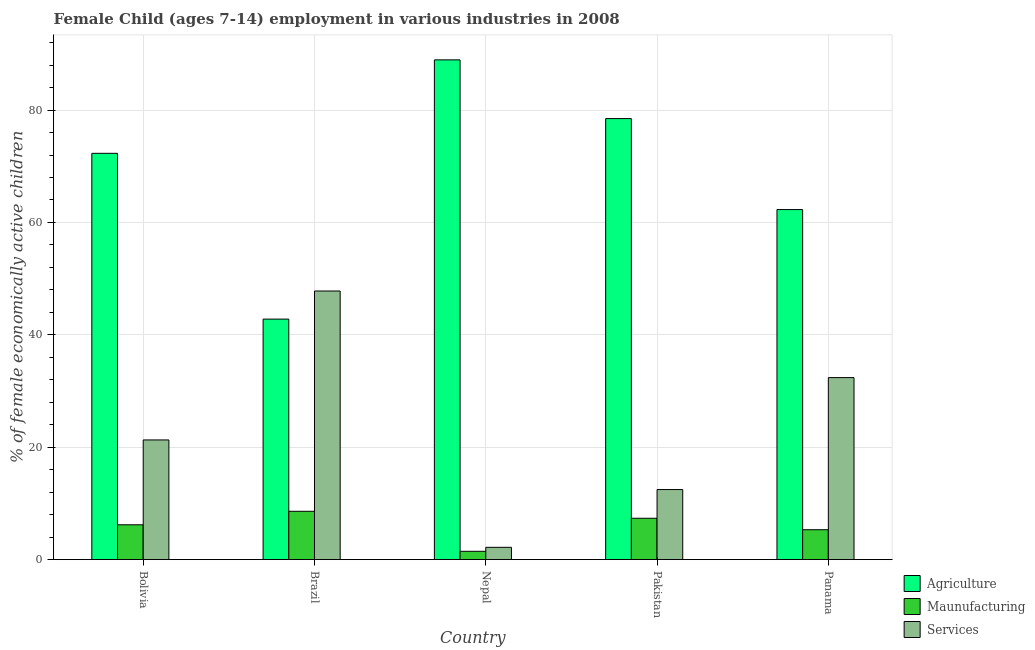How many groups of bars are there?
Make the answer very short. 5. How many bars are there on the 1st tick from the right?
Provide a short and direct response. 3. What is the label of the 2nd group of bars from the left?
Your answer should be compact. Brazil. In how many cases, is the number of bars for a given country not equal to the number of legend labels?
Offer a terse response. 0. What is the percentage of economically active children in services in Pakistan?
Provide a short and direct response. 12.47. Across all countries, what is the maximum percentage of economically active children in agriculture?
Your answer should be very brief. 88.93. Across all countries, what is the minimum percentage of economically active children in manufacturing?
Ensure brevity in your answer.  1.48. In which country was the percentage of economically active children in agriculture maximum?
Offer a terse response. Nepal. In which country was the percentage of economically active children in services minimum?
Make the answer very short. Nepal. What is the total percentage of economically active children in manufacturing in the graph?
Provide a short and direct response. 28.96. What is the difference between the percentage of economically active children in agriculture in Bolivia and that in Nepal?
Keep it short and to the point. -16.63. What is the difference between the percentage of economically active children in agriculture in Bolivia and the percentage of economically active children in manufacturing in Panama?
Make the answer very short. 66.98. What is the average percentage of economically active children in agriculture per country?
Keep it short and to the point. 68.96. What is the difference between the percentage of economically active children in services and percentage of economically active children in manufacturing in Panama?
Provide a short and direct response. 27.07. In how many countries, is the percentage of economically active children in agriculture greater than 32 %?
Provide a succinct answer. 5. What is the ratio of the percentage of economically active children in services in Bolivia to that in Brazil?
Make the answer very short. 0.45. Is the percentage of economically active children in services in Bolivia less than that in Pakistan?
Provide a succinct answer. No. What is the difference between the highest and the second highest percentage of economically active children in agriculture?
Provide a short and direct response. 10.45. What is the difference between the highest and the lowest percentage of economically active children in services?
Your response must be concise. 45.61. In how many countries, is the percentage of economically active children in agriculture greater than the average percentage of economically active children in agriculture taken over all countries?
Give a very brief answer. 3. Is the sum of the percentage of economically active children in services in Brazil and Pakistan greater than the maximum percentage of economically active children in manufacturing across all countries?
Your answer should be compact. Yes. What does the 3rd bar from the left in Brazil represents?
Offer a terse response. Services. What does the 1st bar from the right in Brazil represents?
Make the answer very short. Services. Is it the case that in every country, the sum of the percentage of economically active children in agriculture and percentage of economically active children in manufacturing is greater than the percentage of economically active children in services?
Offer a very short reply. Yes. Are all the bars in the graph horizontal?
Offer a very short reply. No. How many countries are there in the graph?
Your response must be concise. 5. What is the difference between two consecutive major ticks on the Y-axis?
Provide a succinct answer. 20. Are the values on the major ticks of Y-axis written in scientific E-notation?
Your answer should be very brief. No. Does the graph contain grids?
Your answer should be compact. Yes. Where does the legend appear in the graph?
Give a very brief answer. Bottom right. How are the legend labels stacked?
Make the answer very short. Vertical. What is the title of the graph?
Offer a very short reply. Female Child (ages 7-14) employment in various industries in 2008. Does "Agricultural raw materials" appear as one of the legend labels in the graph?
Provide a succinct answer. No. What is the label or title of the Y-axis?
Provide a succinct answer. % of female economically active children. What is the % of female economically active children in Agriculture in Bolivia?
Offer a very short reply. 72.3. What is the % of female economically active children of Services in Bolivia?
Make the answer very short. 21.3. What is the % of female economically active children of Agriculture in Brazil?
Keep it short and to the point. 42.8. What is the % of female economically active children of Services in Brazil?
Ensure brevity in your answer.  47.8. What is the % of female economically active children of Agriculture in Nepal?
Your response must be concise. 88.93. What is the % of female economically active children of Maunufacturing in Nepal?
Provide a short and direct response. 1.48. What is the % of female economically active children in Services in Nepal?
Offer a very short reply. 2.19. What is the % of female economically active children of Agriculture in Pakistan?
Your answer should be very brief. 78.48. What is the % of female economically active children of Maunufacturing in Pakistan?
Offer a terse response. 7.36. What is the % of female economically active children in Services in Pakistan?
Make the answer very short. 12.47. What is the % of female economically active children of Agriculture in Panama?
Ensure brevity in your answer.  62.29. What is the % of female economically active children of Maunufacturing in Panama?
Provide a succinct answer. 5.32. What is the % of female economically active children in Services in Panama?
Your answer should be very brief. 32.39. Across all countries, what is the maximum % of female economically active children of Agriculture?
Provide a short and direct response. 88.93. Across all countries, what is the maximum % of female economically active children of Maunufacturing?
Make the answer very short. 8.6. Across all countries, what is the maximum % of female economically active children of Services?
Provide a succinct answer. 47.8. Across all countries, what is the minimum % of female economically active children in Agriculture?
Provide a short and direct response. 42.8. Across all countries, what is the minimum % of female economically active children in Maunufacturing?
Ensure brevity in your answer.  1.48. Across all countries, what is the minimum % of female economically active children of Services?
Your answer should be very brief. 2.19. What is the total % of female economically active children in Agriculture in the graph?
Provide a short and direct response. 344.8. What is the total % of female economically active children of Maunufacturing in the graph?
Your response must be concise. 28.96. What is the total % of female economically active children in Services in the graph?
Provide a short and direct response. 116.15. What is the difference between the % of female economically active children in Agriculture in Bolivia and that in Brazil?
Give a very brief answer. 29.5. What is the difference between the % of female economically active children in Maunufacturing in Bolivia and that in Brazil?
Your answer should be compact. -2.4. What is the difference between the % of female economically active children of Services in Bolivia and that in Brazil?
Give a very brief answer. -26.5. What is the difference between the % of female economically active children of Agriculture in Bolivia and that in Nepal?
Provide a short and direct response. -16.63. What is the difference between the % of female economically active children in Maunufacturing in Bolivia and that in Nepal?
Provide a succinct answer. 4.72. What is the difference between the % of female economically active children in Services in Bolivia and that in Nepal?
Your response must be concise. 19.11. What is the difference between the % of female economically active children of Agriculture in Bolivia and that in Pakistan?
Ensure brevity in your answer.  -6.18. What is the difference between the % of female economically active children in Maunufacturing in Bolivia and that in Pakistan?
Your answer should be compact. -1.16. What is the difference between the % of female economically active children in Services in Bolivia and that in Pakistan?
Your answer should be very brief. 8.83. What is the difference between the % of female economically active children of Agriculture in Bolivia and that in Panama?
Make the answer very short. 10.01. What is the difference between the % of female economically active children of Maunufacturing in Bolivia and that in Panama?
Offer a very short reply. 0.88. What is the difference between the % of female economically active children in Services in Bolivia and that in Panama?
Keep it short and to the point. -11.09. What is the difference between the % of female economically active children in Agriculture in Brazil and that in Nepal?
Your response must be concise. -46.13. What is the difference between the % of female economically active children in Maunufacturing in Brazil and that in Nepal?
Offer a very short reply. 7.12. What is the difference between the % of female economically active children in Services in Brazil and that in Nepal?
Your response must be concise. 45.61. What is the difference between the % of female economically active children in Agriculture in Brazil and that in Pakistan?
Provide a succinct answer. -35.68. What is the difference between the % of female economically active children of Maunufacturing in Brazil and that in Pakistan?
Your answer should be compact. 1.24. What is the difference between the % of female economically active children of Services in Brazil and that in Pakistan?
Make the answer very short. 35.33. What is the difference between the % of female economically active children of Agriculture in Brazil and that in Panama?
Offer a very short reply. -19.49. What is the difference between the % of female economically active children in Maunufacturing in Brazil and that in Panama?
Your answer should be very brief. 3.28. What is the difference between the % of female economically active children of Services in Brazil and that in Panama?
Your response must be concise. 15.41. What is the difference between the % of female economically active children of Agriculture in Nepal and that in Pakistan?
Make the answer very short. 10.45. What is the difference between the % of female economically active children of Maunufacturing in Nepal and that in Pakistan?
Ensure brevity in your answer.  -5.88. What is the difference between the % of female economically active children of Services in Nepal and that in Pakistan?
Make the answer very short. -10.28. What is the difference between the % of female economically active children of Agriculture in Nepal and that in Panama?
Keep it short and to the point. 26.64. What is the difference between the % of female economically active children in Maunufacturing in Nepal and that in Panama?
Keep it short and to the point. -3.84. What is the difference between the % of female economically active children in Services in Nepal and that in Panama?
Your response must be concise. -30.2. What is the difference between the % of female economically active children in Agriculture in Pakistan and that in Panama?
Your answer should be very brief. 16.19. What is the difference between the % of female economically active children in Maunufacturing in Pakistan and that in Panama?
Give a very brief answer. 2.04. What is the difference between the % of female economically active children of Services in Pakistan and that in Panama?
Offer a terse response. -19.92. What is the difference between the % of female economically active children of Agriculture in Bolivia and the % of female economically active children of Maunufacturing in Brazil?
Provide a short and direct response. 63.7. What is the difference between the % of female economically active children of Maunufacturing in Bolivia and the % of female economically active children of Services in Brazil?
Your response must be concise. -41.6. What is the difference between the % of female economically active children of Agriculture in Bolivia and the % of female economically active children of Maunufacturing in Nepal?
Offer a very short reply. 70.82. What is the difference between the % of female economically active children in Agriculture in Bolivia and the % of female economically active children in Services in Nepal?
Your answer should be compact. 70.11. What is the difference between the % of female economically active children in Maunufacturing in Bolivia and the % of female economically active children in Services in Nepal?
Your answer should be compact. 4.01. What is the difference between the % of female economically active children in Agriculture in Bolivia and the % of female economically active children in Maunufacturing in Pakistan?
Ensure brevity in your answer.  64.94. What is the difference between the % of female economically active children of Agriculture in Bolivia and the % of female economically active children of Services in Pakistan?
Provide a succinct answer. 59.83. What is the difference between the % of female economically active children of Maunufacturing in Bolivia and the % of female economically active children of Services in Pakistan?
Keep it short and to the point. -6.27. What is the difference between the % of female economically active children in Agriculture in Bolivia and the % of female economically active children in Maunufacturing in Panama?
Ensure brevity in your answer.  66.98. What is the difference between the % of female economically active children in Agriculture in Bolivia and the % of female economically active children in Services in Panama?
Make the answer very short. 39.91. What is the difference between the % of female economically active children in Maunufacturing in Bolivia and the % of female economically active children in Services in Panama?
Make the answer very short. -26.19. What is the difference between the % of female economically active children in Agriculture in Brazil and the % of female economically active children in Maunufacturing in Nepal?
Your answer should be very brief. 41.32. What is the difference between the % of female economically active children of Agriculture in Brazil and the % of female economically active children of Services in Nepal?
Provide a short and direct response. 40.61. What is the difference between the % of female economically active children of Maunufacturing in Brazil and the % of female economically active children of Services in Nepal?
Keep it short and to the point. 6.41. What is the difference between the % of female economically active children in Agriculture in Brazil and the % of female economically active children in Maunufacturing in Pakistan?
Provide a succinct answer. 35.44. What is the difference between the % of female economically active children in Agriculture in Brazil and the % of female economically active children in Services in Pakistan?
Provide a short and direct response. 30.33. What is the difference between the % of female economically active children of Maunufacturing in Brazil and the % of female economically active children of Services in Pakistan?
Provide a short and direct response. -3.87. What is the difference between the % of female economically active children of Agriculture in Brazil and the % of female economically active children of Maunufacturing in Panama?
Offer a very short reply. 37.48. What is the difference between the % of female economically active children of Agriculture in Brazil and the % of female economically active children of Services in Panama?
Keep it short and to the point. 10.41. What is the difference between the % of female economically active children of Maunufacturing in Brazil and the % of female economically active children of Services in Panama?
Make the answer very short. -23.79. What is the difference between the % of female economically active children of Agriculture in Nepal and the % of female economically active children of Maunufacturing in Pakistan?
Your response must be concise. 81.57. What is the difference between the % of female economically active children of Agriculture in Nepal and the % of female economically active children of Services in Pakistan?
Give a very brief answer. 76.46. What is the difference between the % of female economically active children of Maunufacturing in Nepal and the % of female economically active children of Services in Pakistan?
Your answer should be compact. -10.99. What is the difference between the % of female economically active children of Agriculture in Nepal and the % of female economically active children of Maunufacturing in Panama?
Give a very brief answer. 83.61. What is the difference between the % of female economically active children of Agriculture in Nepal and the % of female economically active children of Services in Panama?
Your response must be concise. 56.54. What is the difference between the % of female economically active children in Maunufacturing in Nepal and the % of female economically active children in Services in Panama?
Provide a short and direct response. -30.91. What is the difference between the % of female economically active children in Agriculture in Pakistan and the % of female economically active children in Maunufacturing in Panama?
Your answer should be compact. 73.16. What is the difference between the % of female economically active children in Agriculture in Pakistan and the % of female economically active children in Services in Panama?
Your answer should be very brief. 46.09. What is the difference between the % of female economically active children in Maunufacturing in Pakistan and the % of female economically active children in Services in Panama?
Your answer should be very brief. -25.03. What is the average % of female economically active children of Agriculture per country?
Your answer should be very brief. 68.96. What is the average % of female economically active children of Maunufacturing per country?
Offer a terse response. 5.79. What is the average % of female economically active children of Services per country?
Offer a terse response. 23.23. What is the difference between the % of female economically active children of Agriculture and % of female economically active children of Maunufacturing in Bolivia?
Provide a succinct answer. 66.1. What is the difference between the % of female economically active children of Agriculture and % of female economically active children of Services in Bolivia?
Your response must be concise. 51. What is the difference between the % of female economically active children of Maunufacturing and % of female economically active children of Services in Bolivia?
Make the answer very short. -15.1. What is the difference between the % of female economically active children in Agriculture and % of female economically active children in Maunufacturing in Brazil?
Your response must be concise. 34.2. What is the difference between the % of female economically active children in Agriculture and % of female economically active children in Services in Brazil?
Your answer should be compact. -5. What is the difference between the % of female economically active children in Maunufacturing and % of female economically active children in Services in Brazil?
Offer a very short reply. -39.2. What is the difference between the % of female economically active children in Agriculture and % of female economically active children in Maunufacturing in Nepal?
Make the answer very short. 87.45. What is the difference between the % of female economically active children of Agriculture and % of female economically active children of Services in Nepal?
Offer a very short reply. 86.74. What is the difference between the % of female economically active children in Maunufacturing and % of female economically active children in Services in Nepal?
Ensure brevity in your answer.  -0.71. What is the difference between the % of female economically active children in Agriculture and % of female economically active children in Maunufacturing in Pakistan?
Keep it short and to the point. 71.12. What is the difference between the % of female economically active children of Agriculture and % of female economically active children of Services in Pakistan?
Offer a very short reply. 66.01. What is the difference between the % of female economically active children in Maunufacturing and % of female economically active children in Services in Pakistan?
Ensure brevity in your answer.  -5.11. What is the difference between the % of female economically active children of Agriculture and % of female economically active children of Maunufacturing in Panama?
Provide a short and direct response. 56.97. What is the difference between the % of female economically active children in Agriculture and % of female economically active children in Services in Panama?
Keep it short and to the point. 29.9. What is the difference between the % of female economically active children of Maunufacturing and % of female economically active children of Services in Panama?
Your response must be concise. -27.07. What is the ratio of the % of female economically active children of Agriculture in Bolivia to that in Brazil?
Offer a very short reply. 1.69. What is the ratio of the % of female economically active children in Maunufacturing in Bolivia to that in Brazil?
Give a very brief answer. 0.72. What is the ratio of the % of female economically active children of Services in Bolivia to that in Brazil?
Your answer should be very brief. 0.45. What is the ratio of the % of female economically active children of Agriculture in Bolivia to that in Nepal?
Your answer should be very brief. 0.81. What is the ratio of the % of female economically active children in Maunufacturing in Bolivia to that in Nepal?
Give a very brief answer. 4.19. What is the ratio of the % of female economically active children in Services in Bolivia to that in Nepal?
Make the answer very short. 9.73. What is the ratio of the % of female economically active children of Agriculture in Bolivia to that in Pakistan?
Your answer should be compact. 0.92. What is the ratio of the % of female economically active children in Maunufacturing in Bolivia to that in Pakistan?
Give a very brief answer. 0.84. What is the ratio of the % of female economically active children in Services in Bolivia to that in Pakistan?
Keep it short and to the point. 1.71. What is the ratio of the % of female economically active children in Agriculture in Bolivia to that in Panama?
Provide a short and direct response. 1.16. What is the ratio of the % of female economically active children in Maunufacturing in Bolivia to that in Panama?
Provide a succinct answer. 1.17. What is the ratio of the % of female economically active children of Services in Bolivia to that in Panama?
Your answer should be very brief. 0.66. What is the ratio of the % of female economically active children of Agriculture in Brazil to that in Nepal?
Your answer should be very brief. 0.48. What is the ratio of the % of female economically active children in Maunufacturing in Brazil to that in Nepal?
Keep it short and to the point. 5.81. What is the ratio of the % of female economically active children of Services in Brazil to that in Nepal?
Provide a succinct answer. 21.83. What is the ratio of the % of female economically active children of Agriculture in Brazil to that in Pakistan?
Your response must be concise. 0.55. What is the ratio of the % of female economically active children in Maunufacturing in Brazil to that in Pakistan?
Your answer should be compact. 1.17. What is the ratio of the % of female economically active children of Services in Brazil to that in Pakistan?
Your answer should be very brief. 3.83. What is the ratio of the % of female economically active children of Agriculture in Brazil to that in Panama?
Keep it short and to the point. 0.69. What is the ratio of the % of female economically active children of Maunufacturing in Brazil to that in Panama?
Provide a succinct answer. 1.62. What is the ratio of the % of female economically active children in Services in Brazil to that in Panama?
Give a very brief answer. 1.48. What is the ratio of the % of female economically active children in Agriculture in Nepal to that in Pakistan?
Ensure brevity in your answer.  1.13. What is the ratio of the % of female economically active children in Maunufacturing in Nepal to that in Pakistan?
Your response must be concise. 0.2. What is the ratio of the % of female economically active children in Services in Nepal to that in Pakistan?
Give a very brief answer. 0.18. What is the ratio of the % of female economically active children of Agriculture in Nepal to that in Panama?
Offer a very short reply. 1.43. What is the ratio of the % of female economically active children in Maunufacturing in Nepal to that in Panama?
Keep it short and to the point. 0.28. What is the ratio of the % of female economically active children in Services in Nepal to that in Panama?
Ensure brevity in your answer.  0.07. What is the ratio of the % of female economically active children of Agriculture in Pakistan to that in Panama?
Provide a short and direct response. 1.26. What is the ratio of the % of female economically active children of Maunufacturing in Pakistan to that in Panama?
Keep it short and to the point. 1.38. What is the ratio of the % of female economically active children in Services in Pakistan to that in Panama?
Your response must be concise. 0.39. What is the difference between the highest and the second highest % of female economically active children in Agriculture?
Your response must be concise. 10.45. What is the difference between the highest and the second highest % of female economically active children in Maunufacturing?
Offer a terse response. 1.24. What is the difference between the highest and the second highest % of female economically active children in Services?
Provide a short and direct response. 15.41. What is the difference between the highest and the lowest % of female economically active children in Agriculture?
Your answer should be very brief. 46.13. What is the difference between the highest and the lowest % of female economically active children in Maunufacturing?
Offer a terse response. 7.12. What is the difference between the highest and the lowest % of female economically active children of Services?
Provide a short and direct response. 45.61. 